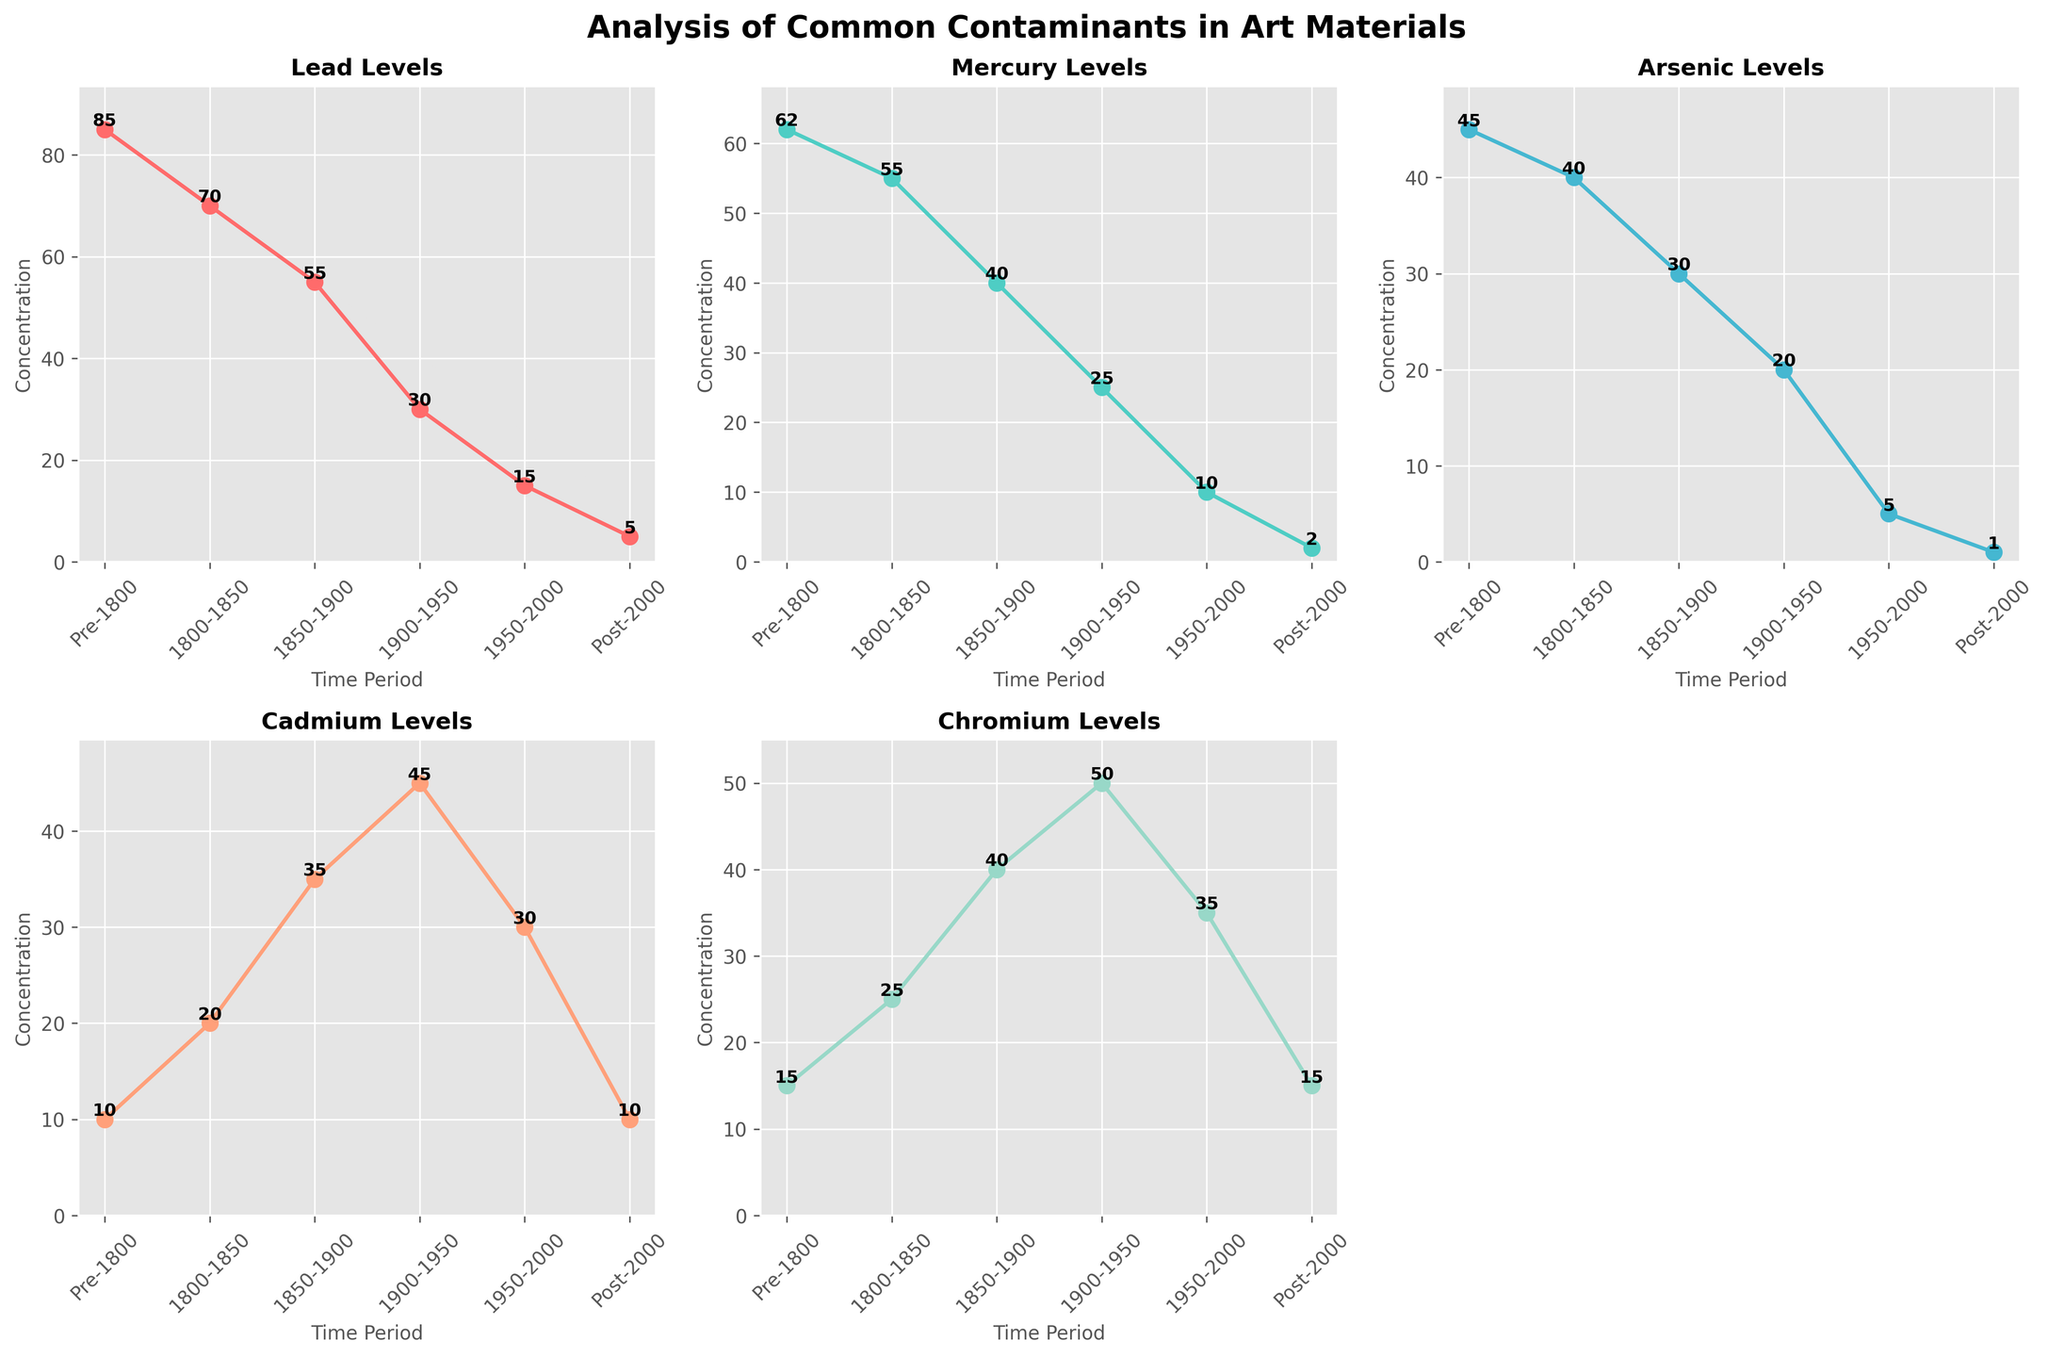Which contaminant has the highest levels in the Pre-1800 period? In the Pre-1800 subplot, Lead has the highest concentration, indicated by the highest data point on the y-axis.
Answer: Lead How has the concentration of Mercury changed from 1800-1850 to Post-2000? The concentration of Mercury decreases from 55 in 1800-1850 to 2 in the Post-2000 period.
Answer: Decreased Which two contaminants have concentrations that increased between 1900-1950 and 1950-2000 periods? By observing the trends across these time periods, Cd (Cadmium) and Cr (Chromium) both have increased levels.
Answer: Cadmium, Chromium Across all time periods, which contaminant shows the most consistent downward trend? Lead consistently decreases from Pre-1800 to Post-2000 without any increases in between.
Answer: Lead What is the difference in concentration of Arsenic between Pre-1800 and Post-2000? The concentration of Arsenic is 45 in Pre-1800 and 1 in Post-2000. The difference is 45 - 1 = 44.
Answer: 44 In which subplot does the 1950-2000 period show a lower concentration compared to the 1900-1950 period? The 1950-2000 subplot for Cadmium shows a decrease from 45 (1900-1950) to 30 (1950-2000).
Answer: Cadmium How many subplots show the highest concentration levels for Post-2000 period being equal to or less than 15? By examining each subplot, Lead, Mercury, Arsenic, and Chromium all have levels equal to or less than 15.
Answer: 4 Which contaminant shows the greatest percentage decrease from 1800-1850 to Post-2000? For each contaminant, calculate ((1800-1850 - Post-2000) / 1800-1850) * 100%. Mercury decreases from 55 to 2, resulting in the greatest percentage decrease: ((55 - 2) / 55) * 100% ≈ 96.4%.
Answer: Mercury What is the average concentration of Chromium across all time periods? Sum the Chromium values (15, 25, 40, 50, 35, 15 = 180) and divide by the number of time periods (6): 180/6 = 30.
Answer: 30 